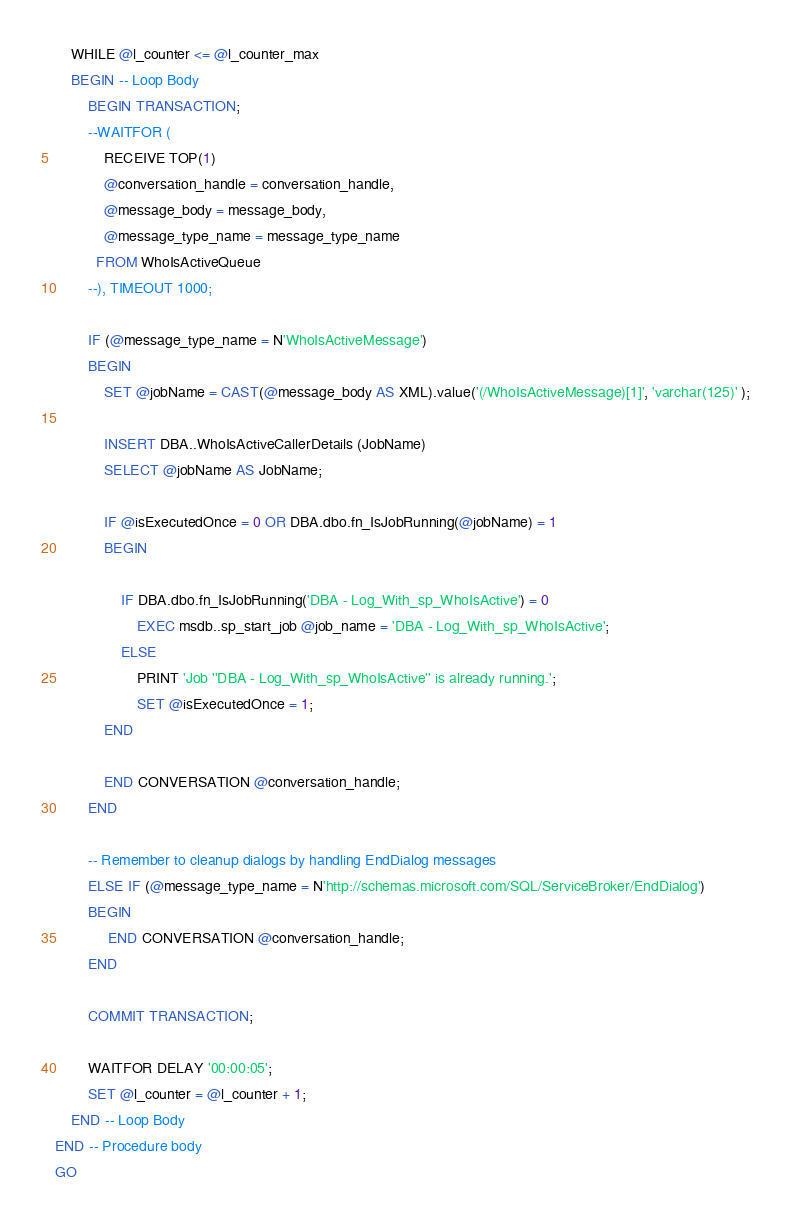<code> <loc_0><loc_0><loc_500><loc_500><_SQL_>	WHILE @l_counter <= @l_counter_max
	BEGIN -- Loop Body
		BEGIN TRANSACTION;
		--WAITFOR ( 
			RECEIVE TOP(1)
			@conversation_handle = conversation_handle,
			@message_body = message_body,
			@message_type_name = message_type_name
		  FROM WhoIsActiveQueue
		--), TIMEOUT 1000;

		IF (@message_type_name = N'WhoIsActiveMessage')
		BEGIN
			SET @jobName = CAST(@message_body AS XML).value('(/WhoIsActiveMessage)[1]', 'varchar(125)' );

			INSERT DBA..WhoIsActiveCallerDetails (JobName)
			SELECT @jobName AS JobName;

			IF @isExecutedOnce = 0 OR DBA.dbo.fn_IsJobRunning(@jobName) = 1
			BEGIN
				
				IF DBA.dbo.fn_IsJobRunning('DBA - Log_With_sp_WhoIsActive') = 0
					EXEC msdb..sp_start_job @job_name = 'DBA - Log_With_sp_WhoIsActive';
				ELSE
					PRINT 'Job ''DBA - Log_With_sp_WhoIsActive'' is already running.';
					SET @isExecutedOnce = 1;
			END

			END CONVERSATION @conversation_handle;
		END

		-- Remember to cleanup dialogs by handling EndDialog messages 
		ELSE IF (@message_type_name = N'http://schemas.microsoft.com/SQL/ServiceBroker/EndDialog')
		BEGIN
			 END CONVERSATION @conversation_handle;
		END

		COMMIT TRANSACTION;

		WAITFOR DELAY '00:00:05';
		SET @l_counter = @l_counter + 1;
	END -- Loop Body
END -- Procedure body
GO</code> 